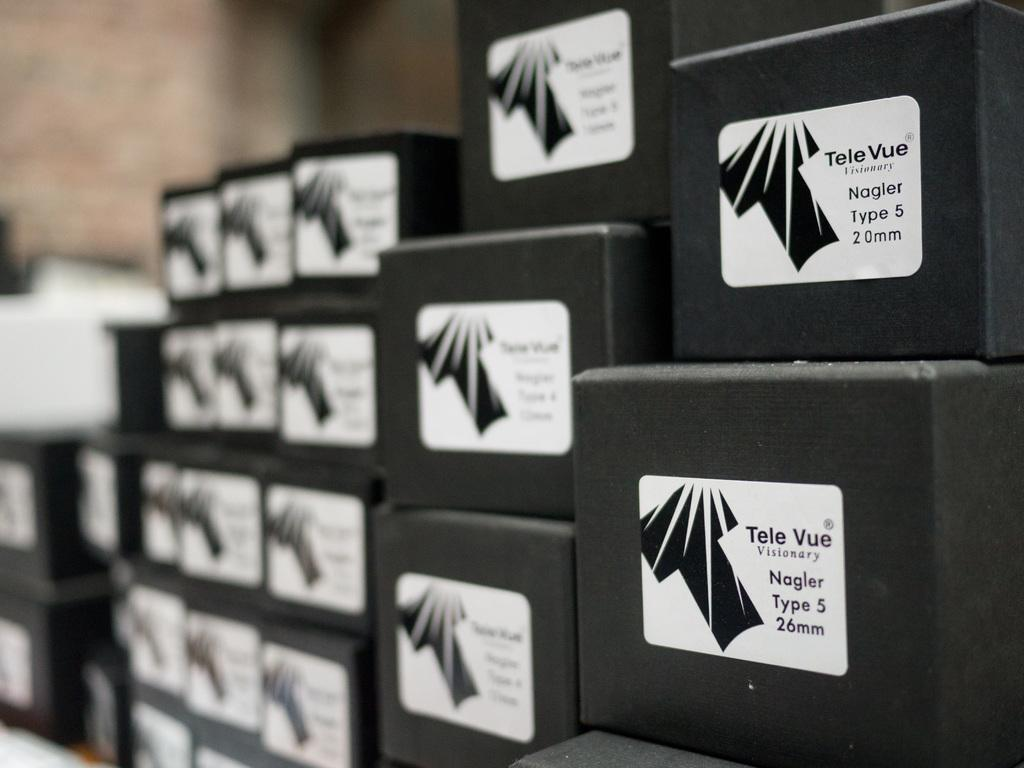<image>
Describe the image concisely. Multiple stacked black  boxes of televue visonary. 